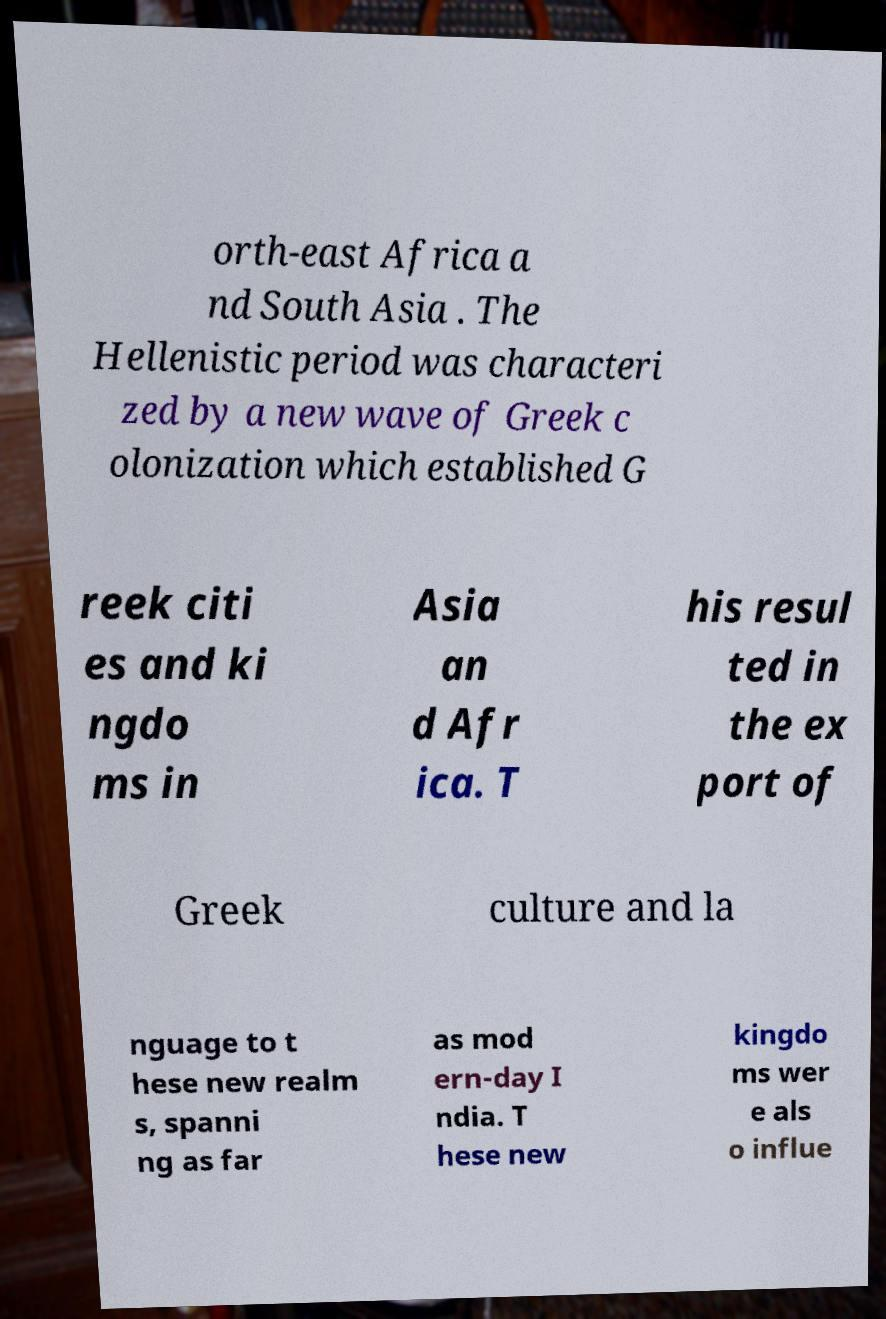Can you accurately transcribe the text from the provided image for me? orth-east Africa a nd South Asia . The Hellenistic period was characteri zed by a new wave of Greek c olonization which established G reek citi es and ki ngdo ms in Asia an d Afr ica. T his resul ted in the ex port of Greek culture and la nguage to t hese new realm s, spanni ng as far as mod ern-day I ndia. T hese new kingdo ms wer e als o influe 